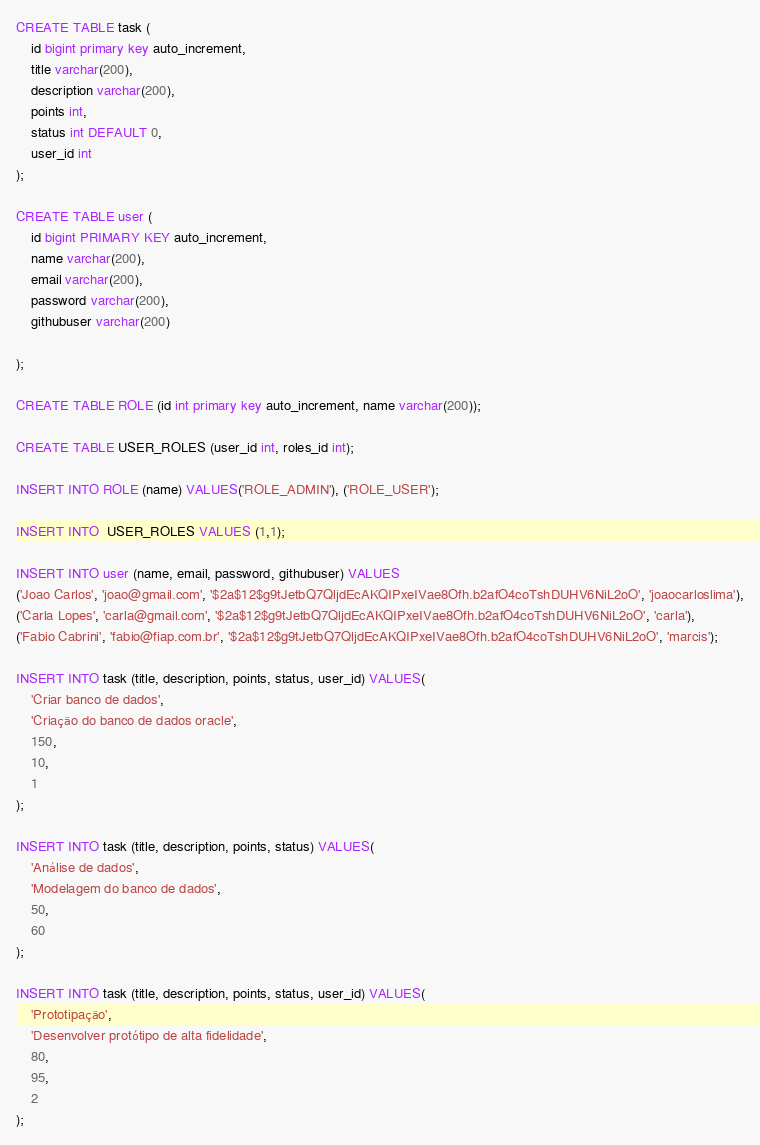Convert code to text. <code><loc_0><loc_0><loc_500><loc_500><_SQL_>CREATE TABLE task (
	id bigint primary key auto_increment,
	title varchar(200),
	description varchar(200),
	points int,
	status int DEFAULT 0,
	user_id int
);

CREATE TABLE user (
	id bigint PRIMARY KEY auto_increment,
	name varchar(200),
	email varchar(200),
	password varchar(200),
	githubuser varchar(200)
	
);

CREATE TABLE ROLE (id int primary key auto_increment, name varchar(200));

CREATE TABLE USER_ROLES (user_id int, roles_id int);

INSERT INTO ROLE (name) VALUES('ROLE_ADMIN'), ('ROLE_USER');

INSERT INTO  USER_ROLES VALUES (1,1);

INSERT INTO user (name, email, password, githubuser) VALUES
('Joao Carlos', 'joao@gmail.com', '$2a$12$g9tJetbQ7QljdEcAKQIPxeIVae8Ofh.b2afO4coTshDUHV6NiL2oO', 'joaocarloslima'),
('Carla Lopes', 'carla@gmail.com', '$2a$12$g9tJetbQ7QljdEcAKQIPxeIVae8Ofh.b2afO4coTshDUHV6NiL2oO', 'carla'),
('Fabio Cabrini', 'fabio@fiap.com.br', '$2a$12$g9tJetbQ7QljdEcAKQIPxeIVae8Ofh.b2afO4coTshDUHV6NiL2oO', 'marcis');

INSERT INTO task (title, description, points, status, user_id) VALUES(
	'Criar banco de dados',
	'Criação do banco de dados oracle',
	150,
	10,
	1
);

INSERT INTO task (title, description, points, status) VALUES(
	'Análise de dados',
	'Modelagem do banco de dados',
	50,
	60
);

INSERT INTO task (title, description, points, status, user_id) VALUES(
	'Prototipação',
	'Desenvolver protótipo de alta fidelidade',
	80,
	95,
	2
);</code> 